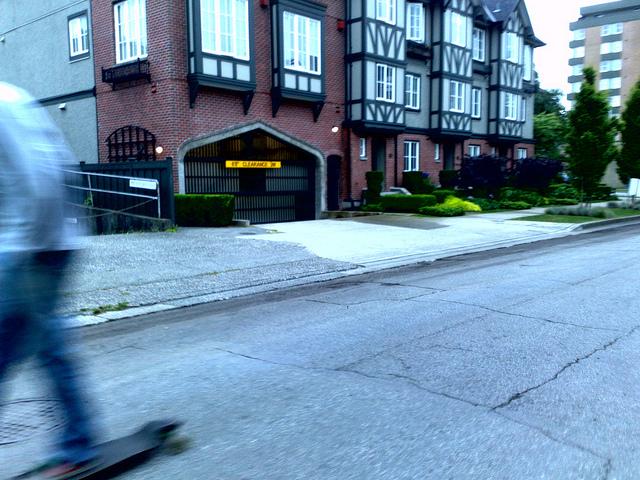Are those residences or businesses in the buildings?
Answer briefly. Residences. Is the man skating?
Short answer required. Yes. Are there any cars on the street?
Keep it brief. No. 